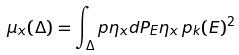Convert formula to latex. <formula><loc_0><loc_0><loc_500><loc_500>\mu _ { x } ( \Delta ) = \int _ { \Delta } \i p { \eta _ { x } } { d P _ { E } \eta _ { x } } \, p _ { k } ( E ) ^ { 2 }</formula> 